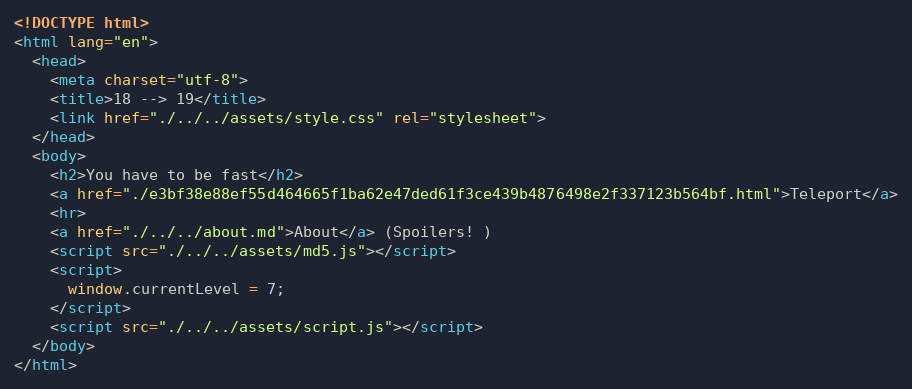Convert code to text. <code><loc_0><loc_0><loc_500><loc_500><_HTML_><!DOCTYPE html>
<html lang="en">
  <head>
    <meta charset="utf-8">
    <title>18 --> 19</title>
    <link href="./../../assets/style.css" rel="stylesheet">
  </head>
  <body>
    <h2>You have to be fast</h2>
    <a href="./e3bf38e88ef55d464665f1ba62e47ded61f3ce439b4876498e2f337123b564bf.html">Teleport</a>
    <hr>
    <a href="./../../about.md">About</a> (Spoilers! )
    <script src="./../../assets/md5.js"></script>
    <script>
      window.currentLevel = 7;
    </script>
    <script src="./../../assets/script.js"></script>
  </body>
</html></code> 